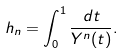Convert formula to latex. <formula><loc_0><loc_0><loc_500><loc_500>h _ { n } = \int _ { 0 } ^ { 1 } \frac { d t } { Y ^ { n } ( t ) } .</formula> 